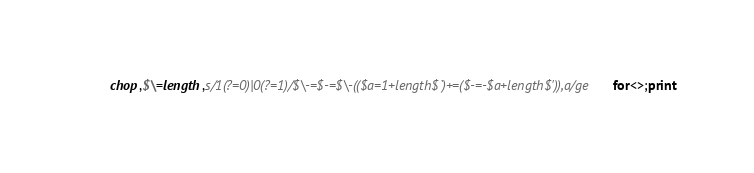<code> <loc_0><loc_0><loc_500><loc_500><_Perl_>chop,$\=length,s/1(?=0)|0(?=1)/$\-=$-=$\-(($a=1+length$`)+=($-=-$a+length$')),a/ge for<>;print</code> 